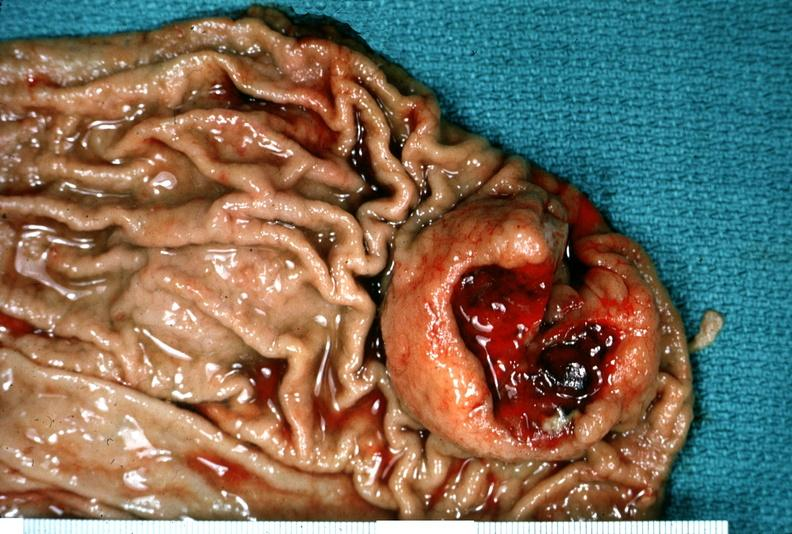does this image show stomach, leiomyoma with ulcerated mucosal surface?
Answer the question using a single word or phrase. Yes 